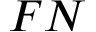Convert formula to latex. <formula><loc_0><loc_0><loc_500><loc_500>F N</formula> 